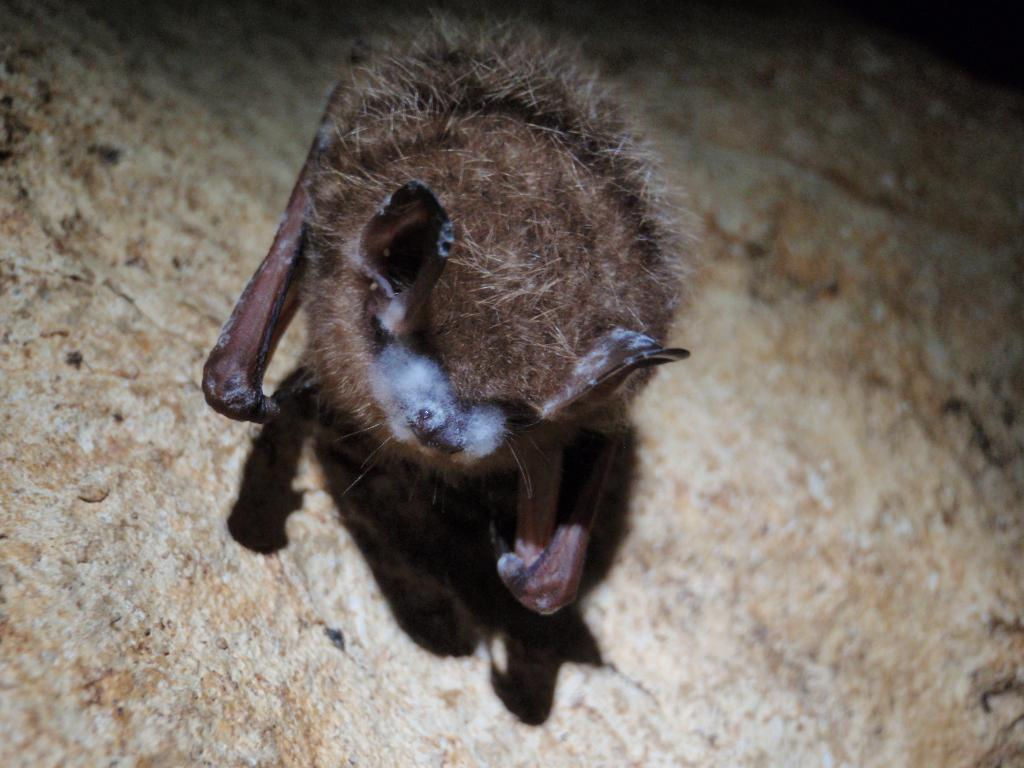What animal is present in the image? There is a bat in the image. What is the bat standing on? The bat is standing on a rock. How far does the bat need to travel to reach the front of the image? The concept of distance or front is not applicable to this image, as it is a two-dimensional representation and does not have a front or back. 